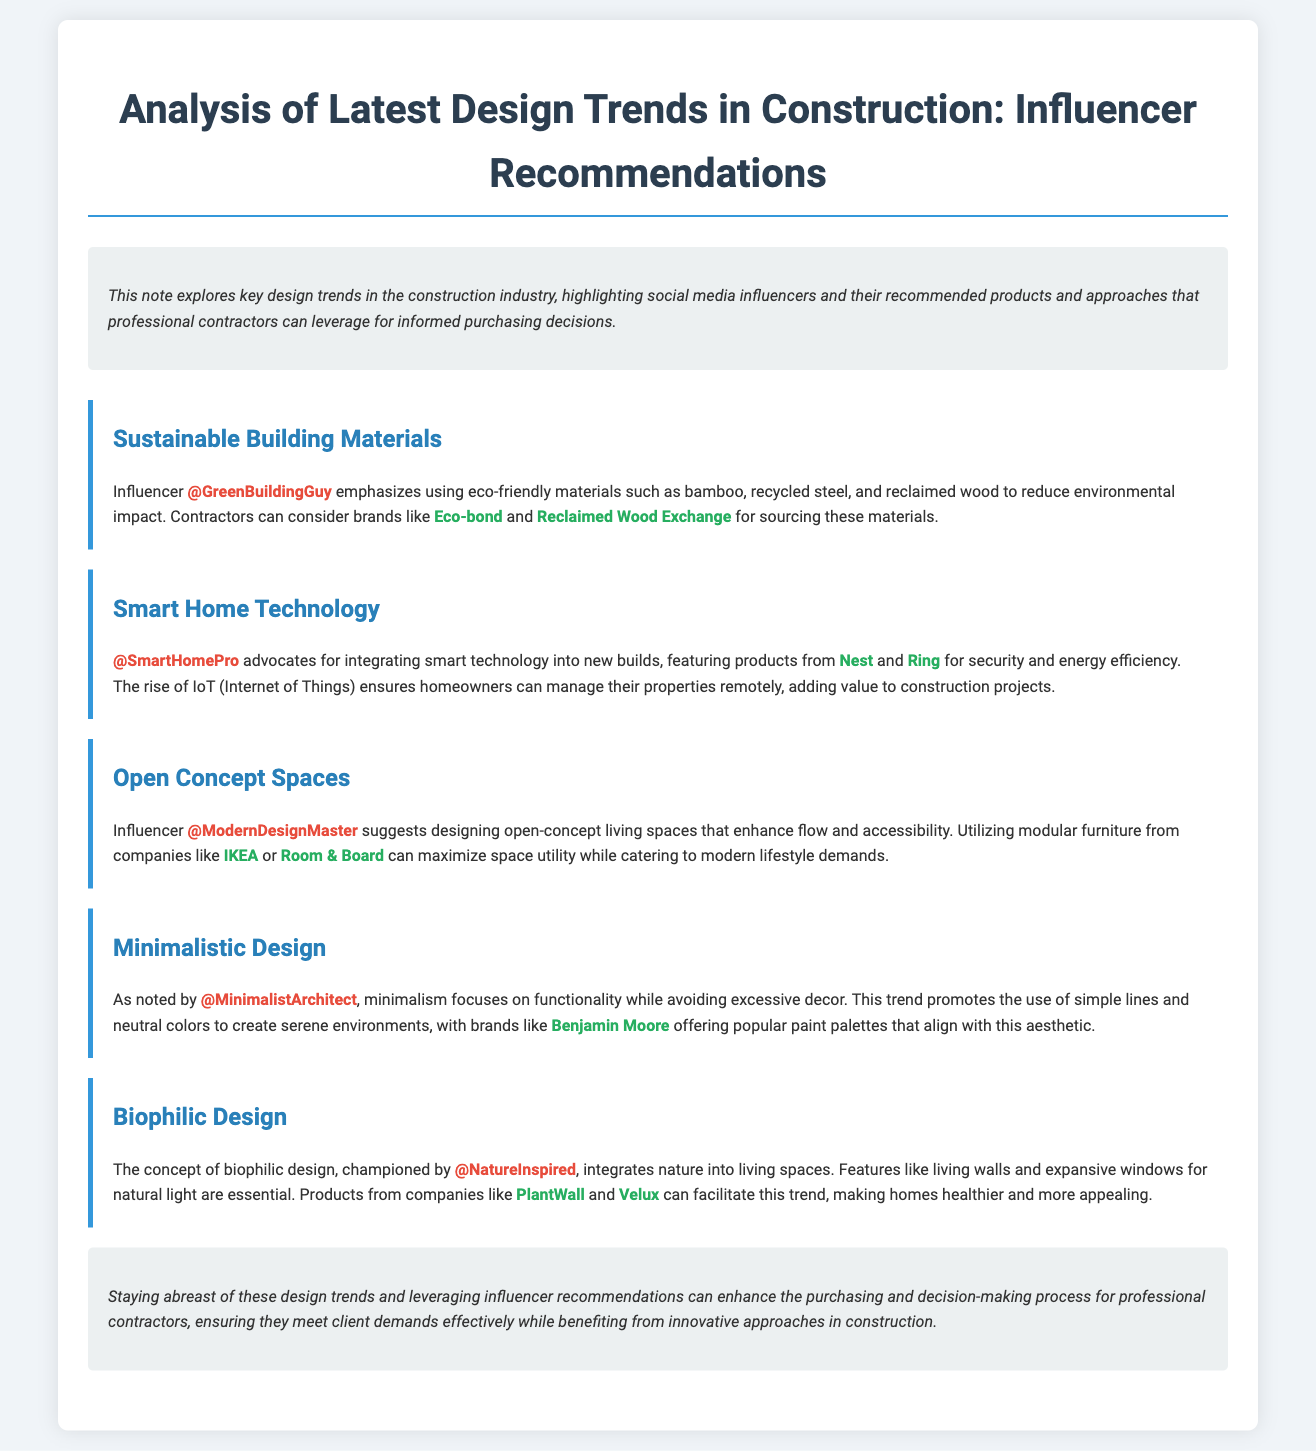What is the main focus of the document? The document primarily analyzes design trends in the construction industry and highlights social media influencers' recommendations.
Answer: Design trends in construction Who is the influencer promoting sustainable building materials? The document clearly states that @GreenBuildingGuy emphasizes the use of eco-friendly materials.
Answer: @GreenBuildingGuy Which product is recommended for smart home technology? The influencer @SmartHomePro recommends specific products from Nest and Ring for smart home technology.
Answer: Nest and Ring What design trend focuses on enhanced flow and accessibility? The trend discussed that highlights open spaces for better flow and accessibility is mentioned under the title "Open Concept Spaces."
Answer: Open Concept Spaces Which color palette is associated with minimalistic design? Neutral colors are integral to the aesthetic promoted by the influencer regarding minimalistic design.
Answer: Neutral colors What does biophilic design integrate into living spaces? Biophilic design aims to integrate natural elements into the design of modern living spaces.
Answer: Nature Which company offers popular paint palettes? The document notes Benjamin Moore as a brand that provides paint palettes aligning with minimalistic design.
Answer: Benjamin Moore What can contractors enhance by leveraging influencer recommendations? Utilizing influencer feedback enhances the purchasing and decision-making process for contractors in construction.
Answer: Purchasing decisions What is the overall aim of staying updated with design trends? The document indicates that staying updated helps contractors meet client demands effectively while adopting innovative construction approaches.
Answer: Meet client demands effectively 